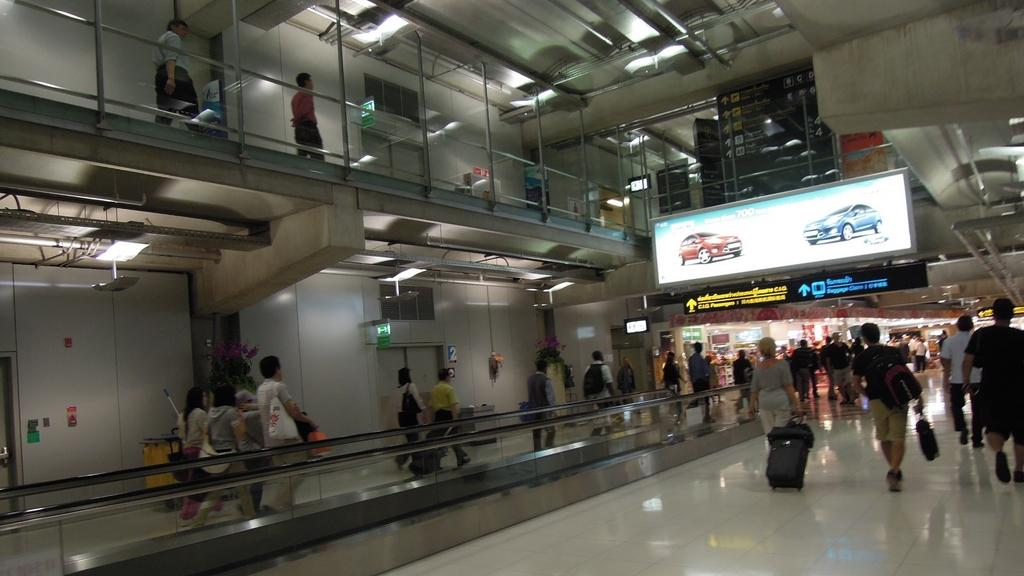What type of setting is shown in the image? The image appears to depict an underground setting. What are the people in the image doing? There are people walking on the ground in the image. Can you describe any objects or structures in the image? There is a screen on the right side of the image. What type of beast can be seen roaring in the image? There is no beast present in the image; it depicts an underground setting with people walking and a screen on the right side. How many cannons are visible in the image? There are no cannons present in the image. 